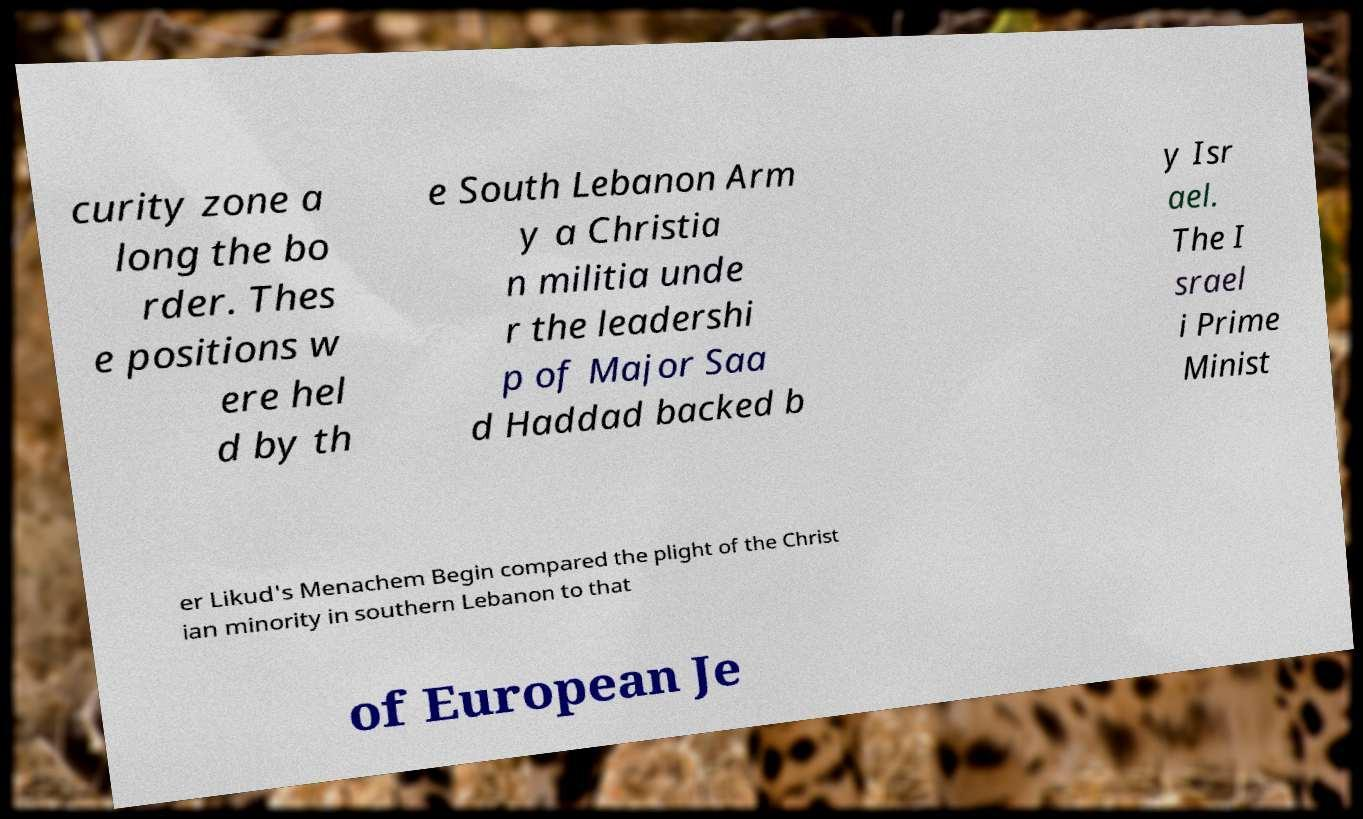Can you accurately transcribe the text from the provided image for me? curity zone a long the bo rder. Thes e positions w ere hel d by th e South Lebanon Arm y a Christia n militia unde r the leadershi p of Major Saa d Haddad backed b y Isr ael. The I srael i Prime Minist er Likud's Menachem Begin compared the plight of the Christ ian minority in southern Lebanon to that of European Je 